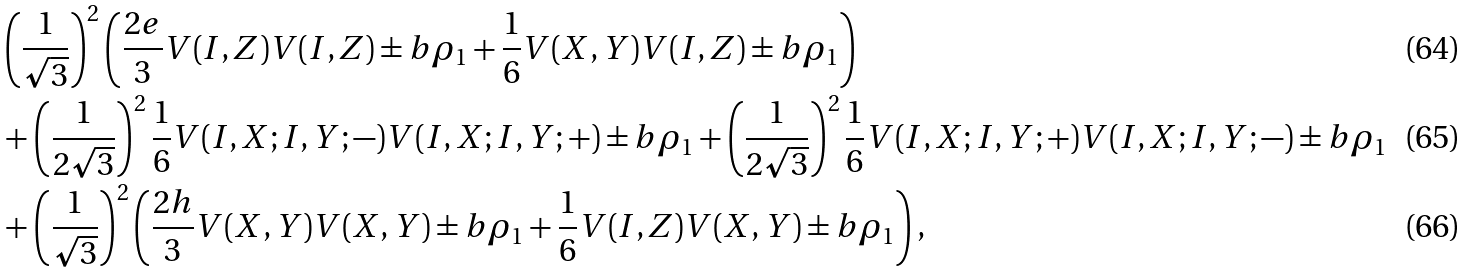<formula> <loc_0><loc_0><loc_500><loc_500>& \left ( \frac { 1 } { \sqrt { 3 } } \right ) ^ { 2 } \left ( \frac { 2 e } { 3 } V ( I , Z ) V ( I , Z ) \pm b { \rho } _ { 1 } + \frac { 1 } { 6 } V ( X , Y ) V ( I , Z ) \pm b { \rho } _ { 1 } \right ) \\ & + \left ( \frac { 1 } { 2 \sqrt { 3 } } \right ) ^ { 2 } \frac { 1 } { 6 } V ( I , X ; I , Y ; - ) V ( I , X ; I , Y ; + ) \pm b { \rho } _ { 1 } + \left ( \frac { 1 } { 2 \sqrt { 3 } } \right ) ^ { 2 } \frac { 1 } { 6 } V ( I , X ; I , Y ; + ) V ( I , X ; I , Y ; - ) \pm b { \rho } _ { 1 } \\ & + \left ( \frac { 1 } { \sqrt { 3 } } \right ) ^ { 2 } \left ( \frac { 2 h } { 3 } V ( X , Y ) V ( X , Y ) \pm b { \rho } _ { 1 } + \frac { 1 } { 6 } V ( I , Z ) V ( X , Y ) \pm b { \rho } _ { 1 } \right ) ,</formula> 